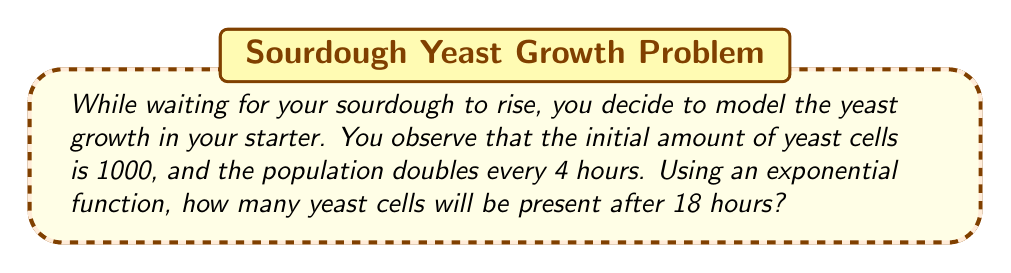Could you help me with this problem? Let's approach this step-by-step:

1) The general form of an exponential growth function is:
   $$ A(t) = A_0 \cdot b^t $$
   where $A(t)$ is the amount at time $t$, $A_0$ is the initial amount, and $b$ is the growth factor.

2) We're given:
   - Initial amount, $A_0 = 1000$ cells
   - The population doubles every 4 hours
   - We need to find the amount after 18 hours

3) To find $b$, we use the doubling time:
   $$ 2 = b^4 $$
   $$ b = 2^{\frac{1}{4}} = \sqrt[4]{2} \approx 1.1892 $$

4) Now we can write our function:
   $$ A(t) = 1000 \cdot (1.1892)^t $$
   where $t$ is measured in 4-hour intervals

5) For 18 hours, $t = \frac{18}{4} = 4.5$

6) Plugging this into our function:
   $$ A(4.5) = 1000 \cdot (1.1892)^{4.5} $$

7) Calculate:
   $$ A(4.5) = 1000 \cdot 2.1544 = 2154.4 $$

8) Round to the nearest whole number, as we can't have partial yeast cells.
Answer: 2154 yeast cells 